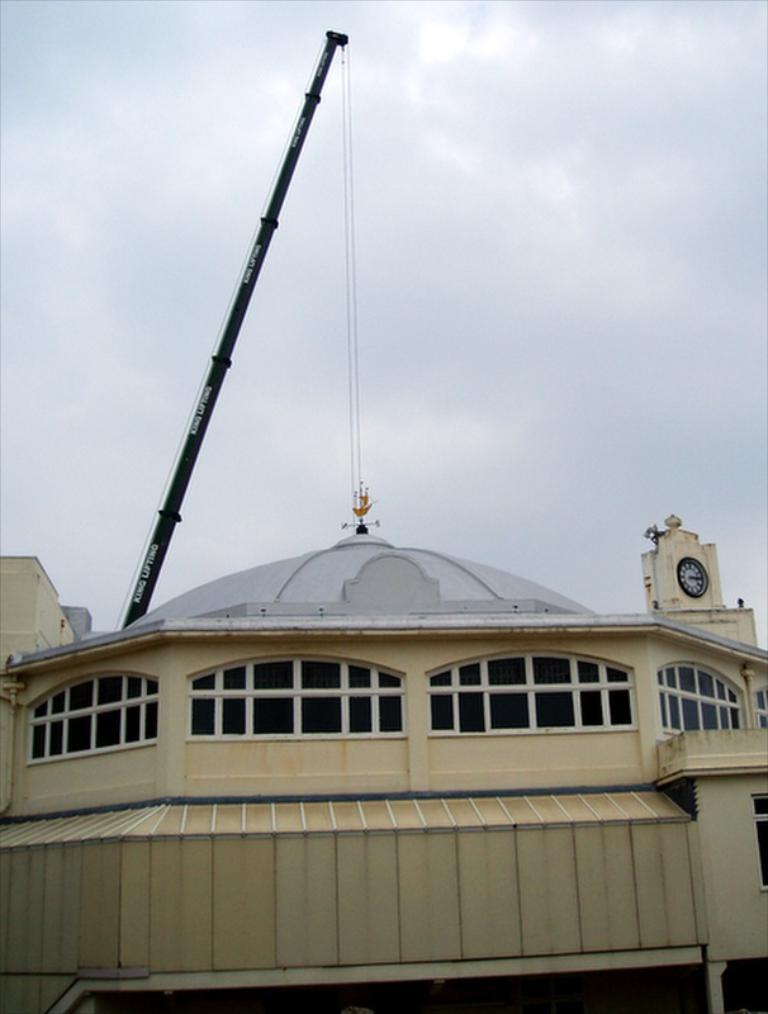What type of structure is present in the image? There is a building in the image. What specific feature can be seen on the building? There is a clock tower in the image. What piece of equipment is visible in the image? There is a construction crane in the image. What can be seen in the background of the image? The sky is visible in the background of the image. What is the condition of the sky in the image? There are clouds in the sky. What type of root can be seen growing from the construction crane in the image? There is no root growing from the construction crane in the image. What purpose does the stone serve in the image? There is no stone present in the image, so it cannot serve any purpose. 